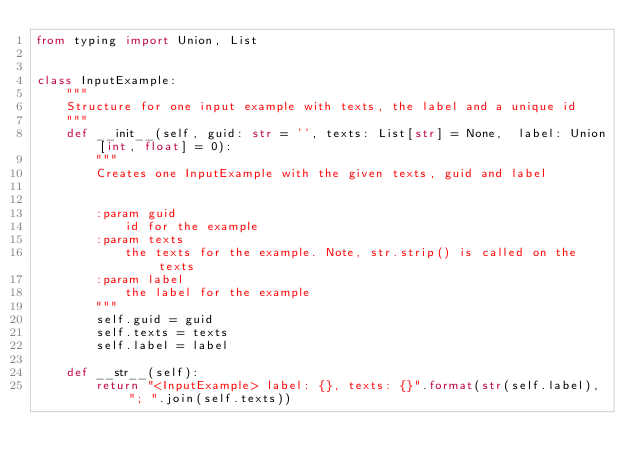Convert code to text. <code><loc_0><loc_0><loc_500><loc_500><_Python_>from typing import Union, List


class InputExample:
    """
    Structure for one input example with texts, the label and a unique id
    """
    def __init__(self, guid: str = '', texts: List[str] = None,  label: Union[int, float] = 0):
        """
        Creates one InputExample with the given texts, guid and label


        :param guid
            id for the example
        :param texts
            the texts for the example. Note, str.strip() is called on the texts
        :param label
            the label for the example
        """
        self.guid = guid
        self.texts = texts
        self.label = label

    def __str__(self):
        return "<InputExample> label: {}, texts: {}".format(str(self.label), "; ".join(self.texts))</code> 